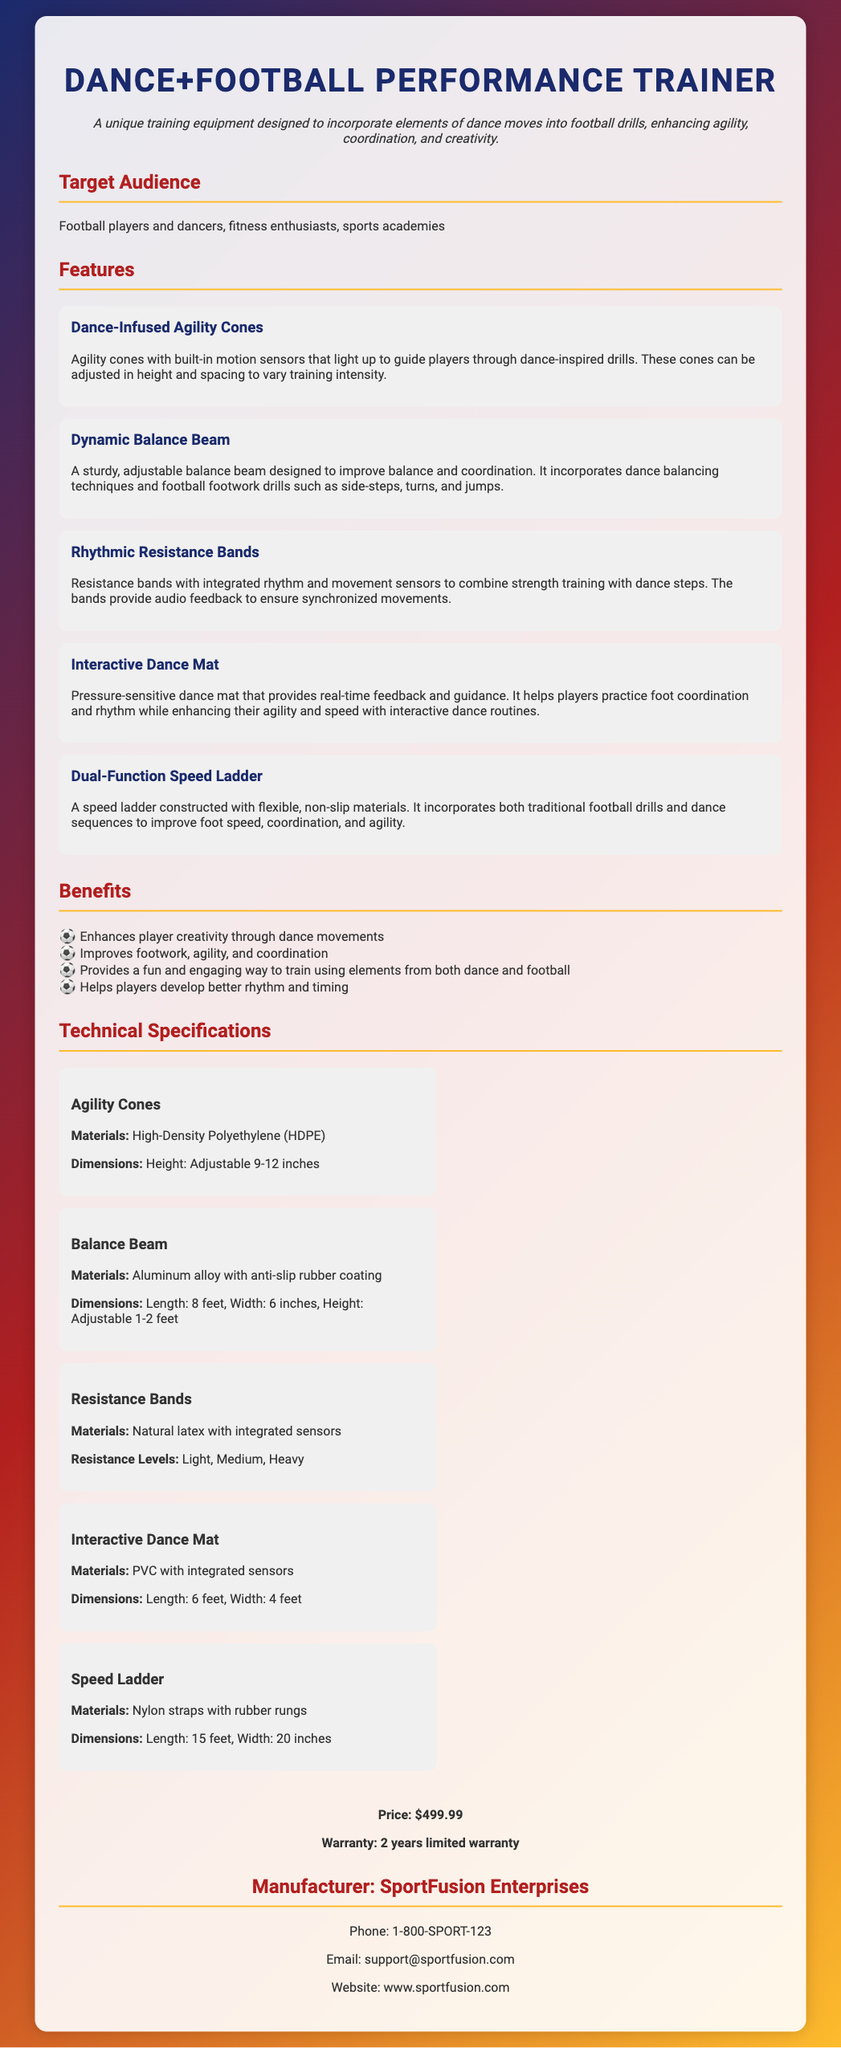what is the price of the product? The price of the Dance+Football Performance Trainer is stated in the document.
Answer: $499.99 what is the warranty period? The warranty period for the product is specified in the document.
Answer: 2 years limited warranty who is the manufacturer? The document lists the manufacturer of the product.
Answer: SportFusion Enterprises what unique feature helps improve rhythm? The document mentions a feature that aids in practicing rhythm through dance.
Answer: Interactive Dance Mat how many different resistance levels do the bands offer? The document states the number of resistance levels available for the resistance bands.
Answer: 3 what are the materials used for the agility cones? The document provides the materials used in making the agility cones.
Answer: High-Density Polyethylene (HDPE) which feature combines dance with balance and footwork? The document describes a feature that integrates dance balancing techniques with footwork drills.
Answer: Dynamic Balance Beam what is the dimension of the interactive dance mat? The document includes the dimensions of the interactive dance mat.
Answer: Length: 6 feet, Width: 4 feet how do the agility cones enhance training intensity? The document explains how the agility cones can be adjusted for training.
Answer: Height and spacing adjustment 